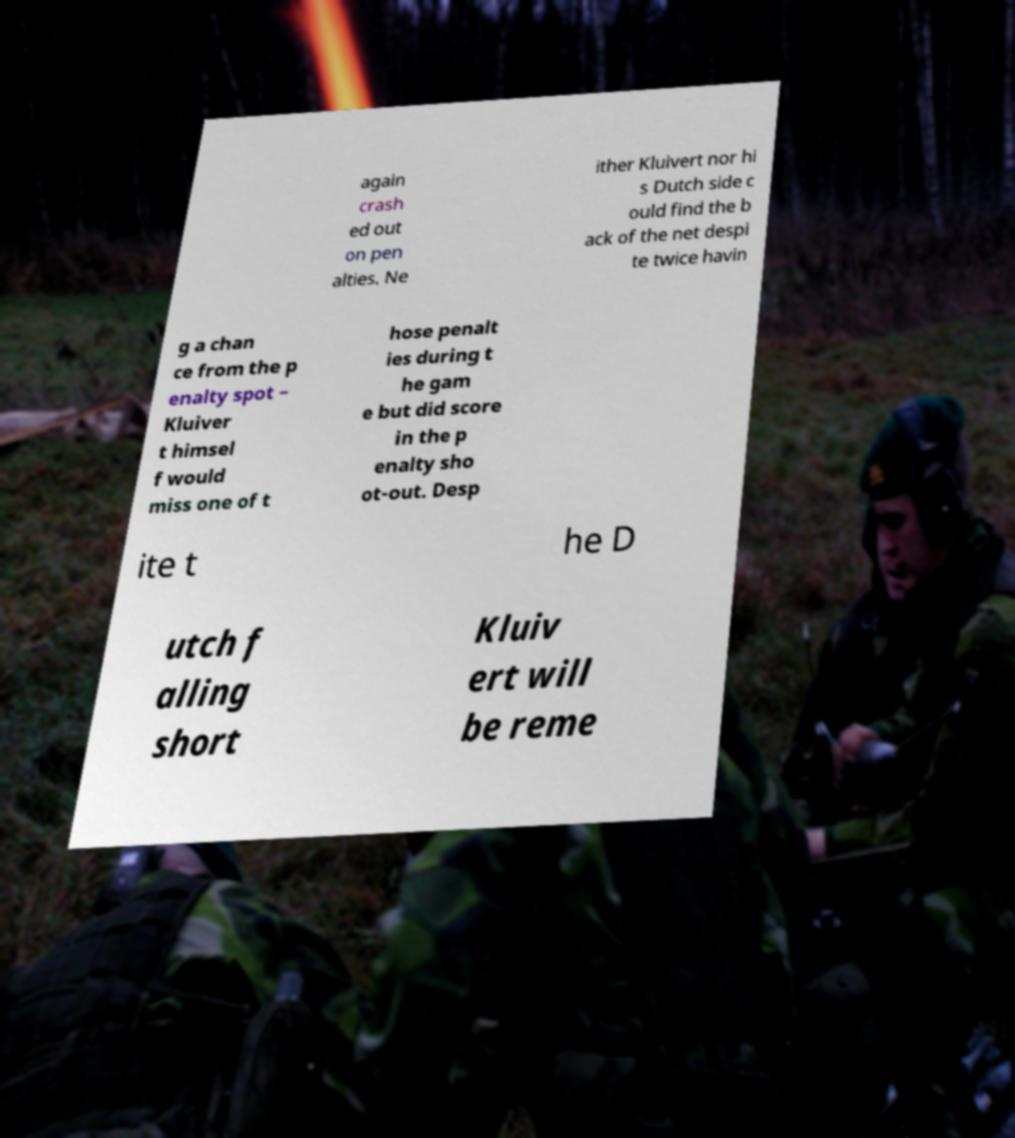I need the written content from this picture converted into text. Can you do that? again crash ed out on pen alties. Ne ither Kluivert nor hi s Dutch side c ould find the b ack of the net despi te twice havin g a chan ce from the p enalty spot – Kluiver t himsel f would miss one of t hose penalt ies during t he gam e but did score in the p enalty sho ot-out. Desp ite t he D utch f alling short Kluiv ert will be reme 